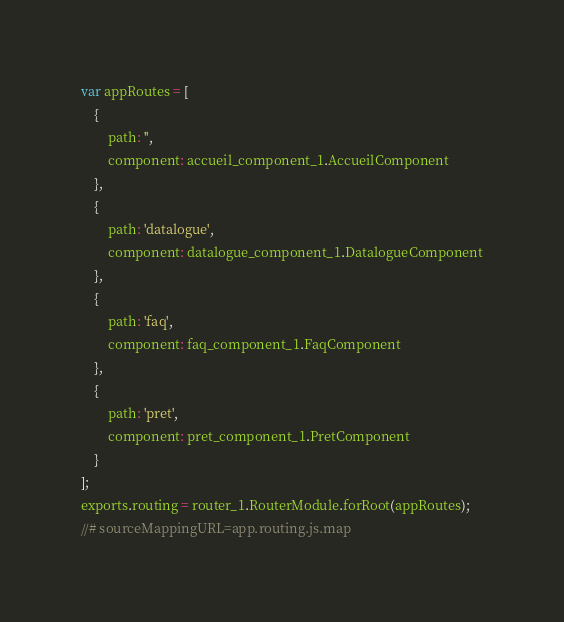<code> <loc_0><loc_0><loc_500><loc_500><_JavaScript_>var appRoutes = [
    {
        path: '',
        component: accueil_component_1.AccueilComponent
    },
    {
        path: 'datalogue',
        component: datalogue_component_1.DatalogueComponent
    },
    {
        path: 'faq',
        component: faq_component_1.FaqComponent
    },
    {
        path: 'pret',
        component: pret_component_1.PretComponent
    }
];
exports.routing = router_1.RouterModule.forRoot(appRoutes);
//# sourceMappingURL=app.routing.js.map</code> 